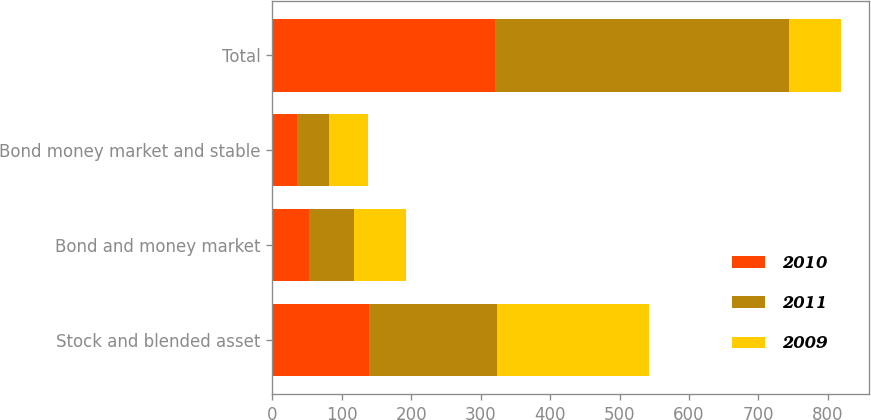<chart> <loc_0><loc_0><loc_500><loc_500><stacked_bar_chart><ecel><fcel>Stock and blended asset<fcel>Bond and money market<fcel>Bond money market and stable<fcel>Total<nl><fcel>2010<fcel>139.5<fcel>52.3<fcel>36.2<fcel>321.3<nl><fcel>2011<fcel>184.7<fcel>66.1<fcel>45.6<fcel>422.6<nl><fcel>2009<fcel>217.6<fcel>74.5<fcel>55.4<fcel>74.5<nl></chart> 